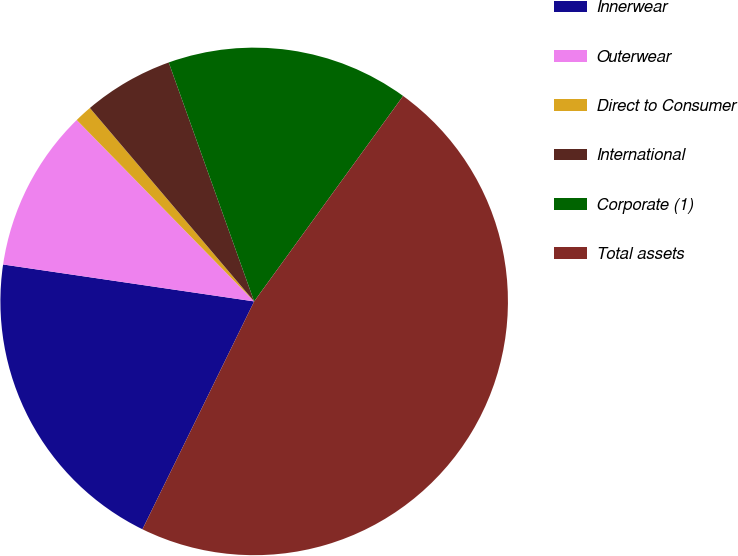Convert chart. <chart><loc_0><loc_0><loc_500><loc_500><pie_chart><fcel>Innerwear<fcel>Outerwear<fcel>Direct to Consumer<fcel>International<fcel>Corporate (1)<fcel>Total assets<nl><fcel>20.07%<fcel>10.35%<fcel>1.12%<fcel>5.74%<fcel>15.45%<fcel>47.27%<nl></chart> 